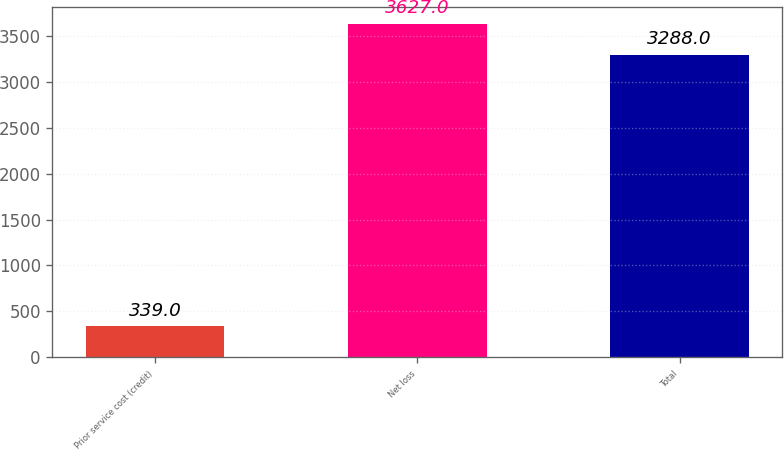Convert chart to OTSL. <chart><loc_0><loc_0><loc_500><loc_500><bar_chart><fcel>Prior service cost (credit)<fcel>Net loss<fcel>Total<nl><fcel>339<fcel>3627<fcel>3288<nl></chart> 